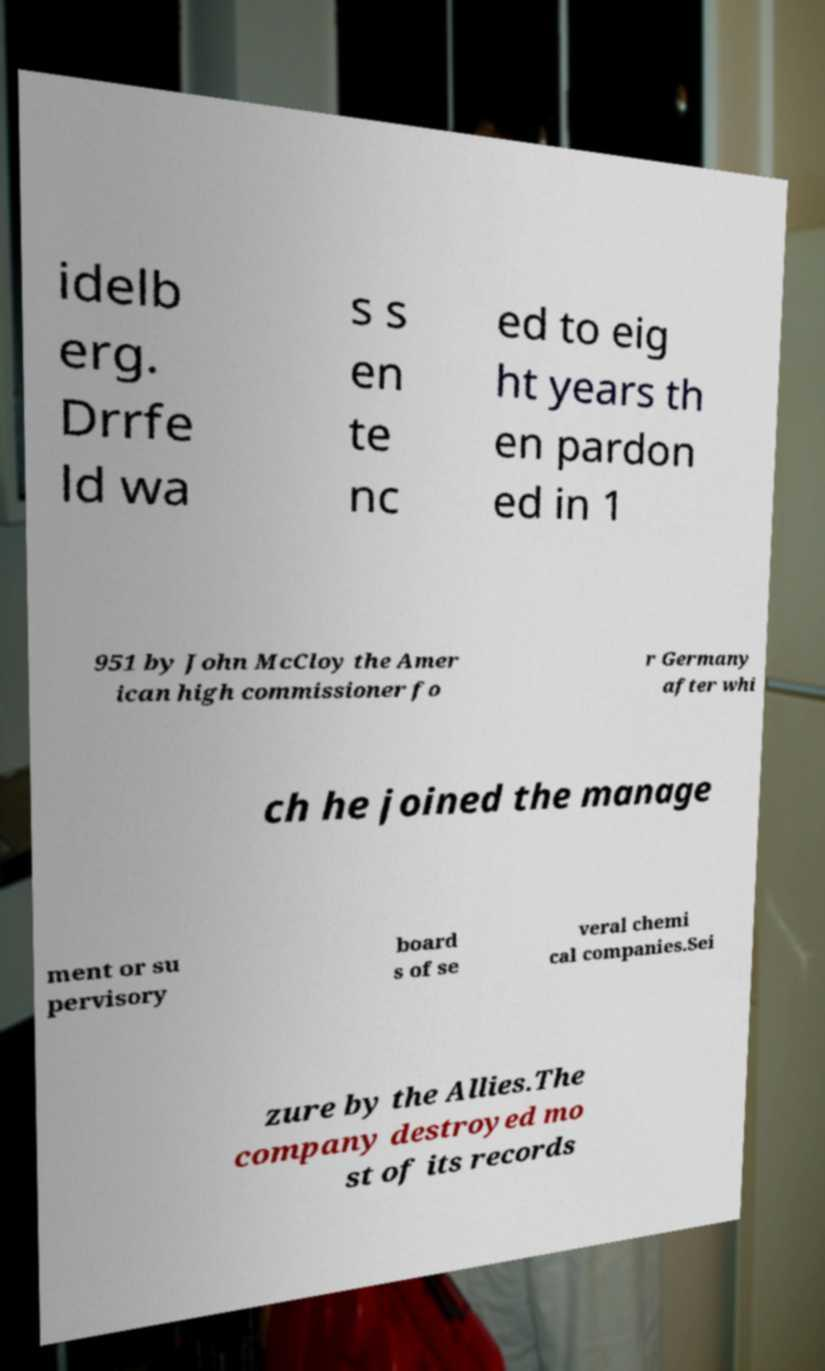I need the written content from this picture converted into text. Can you do that? idelb erg. Drrfe ld wa s s en te nc ed to eig ht years th en pardon ed in 1 951 by John McCloy the Amer ican high commissioner fo r Germany after whi ch he joined the manage ment or su pervisory board s of se veral chemi cal companies.Sei zure by the Allies.The company destroyed mo st of its records 